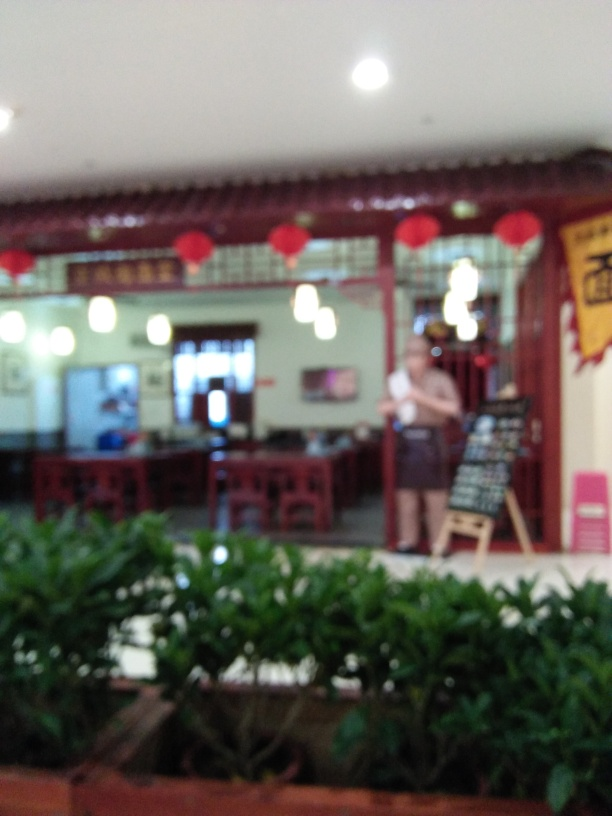Describe the mood or atmosphere the setting conveys. Although the image is blurred, one can perceive a casual and inviting atmosphere, potentially indicative of a friendly social space. The warm lighting and traditional decor, like the red lanterns, may suggest a festive or celebratory mood, often associated with dining experiences in a cultural context. 